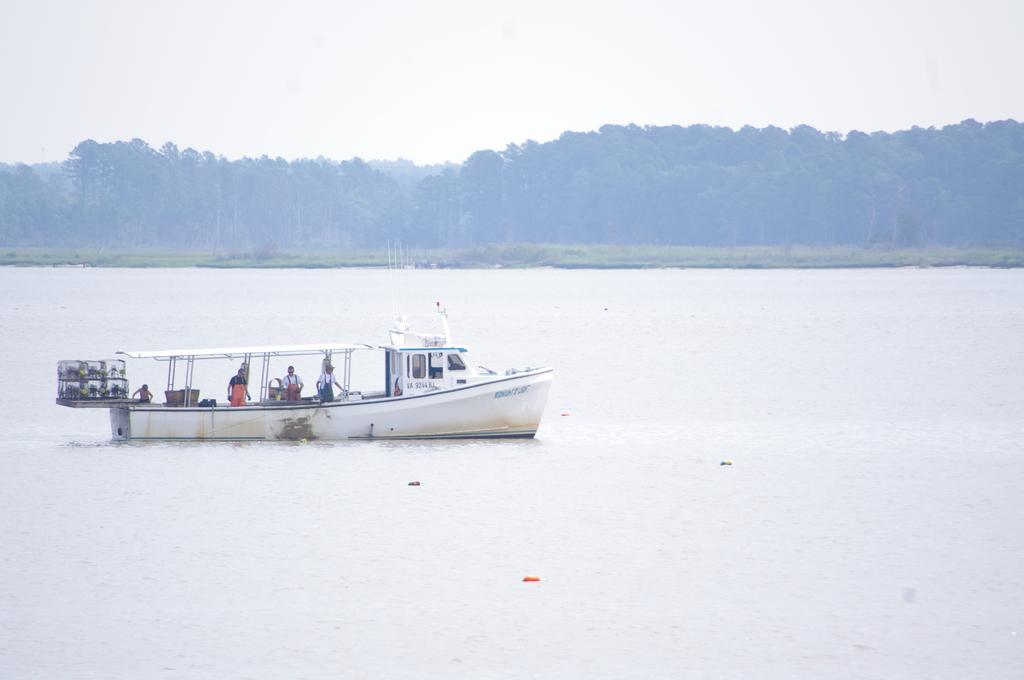What is the main subject of the image? The main subject of the image is a boat above the water. Are there any people on the boat? Yes, there are people on the boat. What can be seen in the distance from the boat? Trees are visible in the distance. How many cats are visible on the boat in the image? There are no cats visible on the boat in the image. Can you describe the crowd of people on the boat? There is no crowd of people on the boat; the image only shows a few people. 